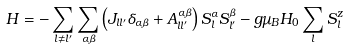<formula> <loc_0><loc_0><loc_500><loc_500>H = - \sum _ { l \ne l ^ { \prime } } \sum _ { \alpha \beta } \left ( J _ { l l ^ { \prime } } \delta _ { \alpha \beta } + A ^ { \alpha \beta } _ { l l ^ { \prime } } \right ) S _ { l } ^ { \alpha } S _ { l ^ { \prime } } ^ { \beta } - g \mu _ { B } H _ { 0 } \sum _ { l } S _ { l } ^ { z }</formula> 